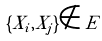<formula> <loc_0><loc_0><loc_500><loc_500>\{ X _ { i } , X _ { j } \} \notin E</formula> 